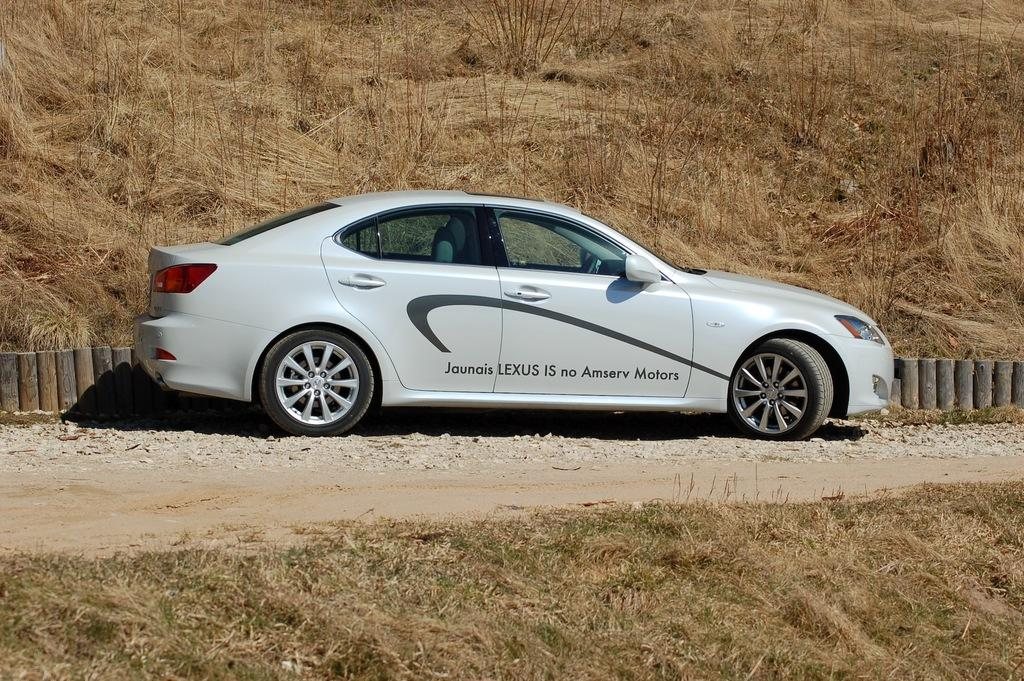What is the main subject in the image? There is a car on the road in the image. Where is the car located in the image? The car is in the middle of the image. What type of terrain is visible at the bottom of the image? There is a grassy land at the bottom of the image. What type of terrain is visible at the top of the image? There is a grassy land at the top of the image. How does the car's thumb affect its speed in the image? Cars do not have thumbs, so this question is not applicable to the image. 